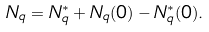<formula> <loc_0><loc_0><loc_500><loc_500>N _ { q } = N _ { q } ^ { * } + N _ { q } ( 0 ) - N _ { q } ^ { * } ( 0 ) .</formula> 